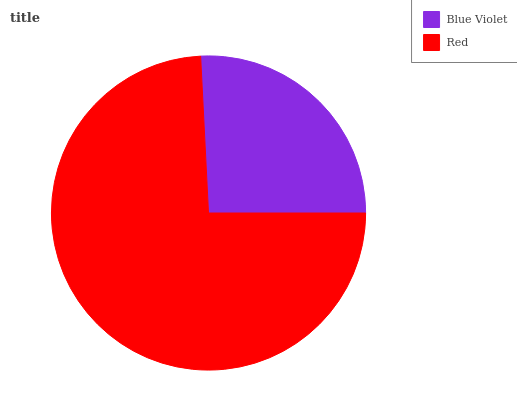Is Blue Violet the minimum?
Answer yes or no. Yes. Is Red the maximum?
Answer yes or no. Yes. Is Red the minimum?
Answer yes or no. No. Is Red greater than Blue Violet?
Answer yes or no. Yes. Is Blue Violet less than Red?
Answer yes or no. Yes. Is Blue Violet greater than Red?
Answer yes or no. No. Is Red less than Blue Violet?
Answer yes or no. No. Is Red the high median?
Answer yes or no. Yes. Is Blue Violet the low median?
Answer yes or no. Yes. Is Blue Violet the high median?
Answer yes or no. No. Is Red the low median?
Answer yes or no. No. 